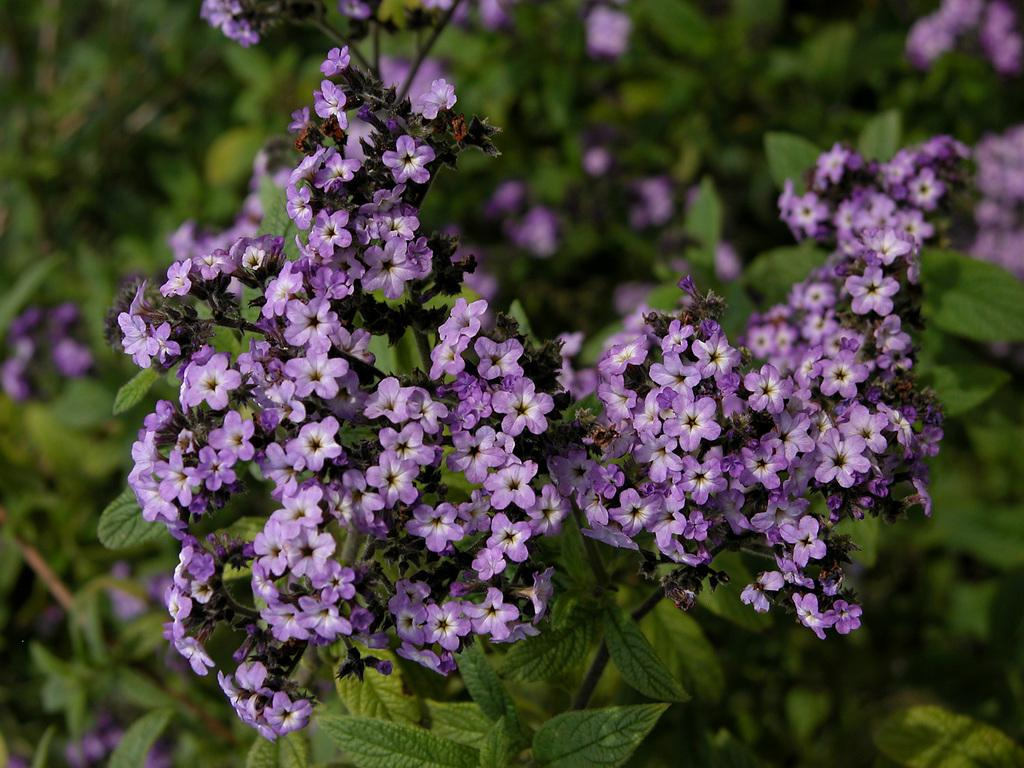What type of flowers can be seen in the image? There are purple color flowers in the image. What other elements can be seen in the image besides the flowers? There are green leaves in the image. Can you describe the background of the image? The background of the image is blurred. How much income does the deer in the image earn per year? There is no deer present in the image, so it is not possible to determine its income. 